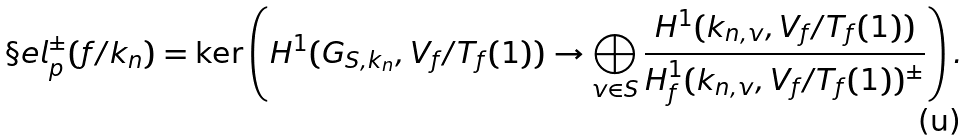<formula> <loc_0><loc_0><loc_500><loc_500>\S e l _ { p } ^ { \pm } ( f / k _ { n } ) = \ker \left ( H ^ { 1 } ( G _ { S , k _ { n } } , V _ { f } / T _ { f } ( 1 ) ) \rightarrow \bigoplus _ { v \in S } \frac { H ^ { 1 } ( k _ { n , v } , V _ { f } / T _ { f } ( 1 ) ) } { H ^ { 1 } _ { f } ( k _ { n , v } , V _ { f } / T _ { f } ( 1 ) ) ^ { \pm } } \right ) .</formula> 